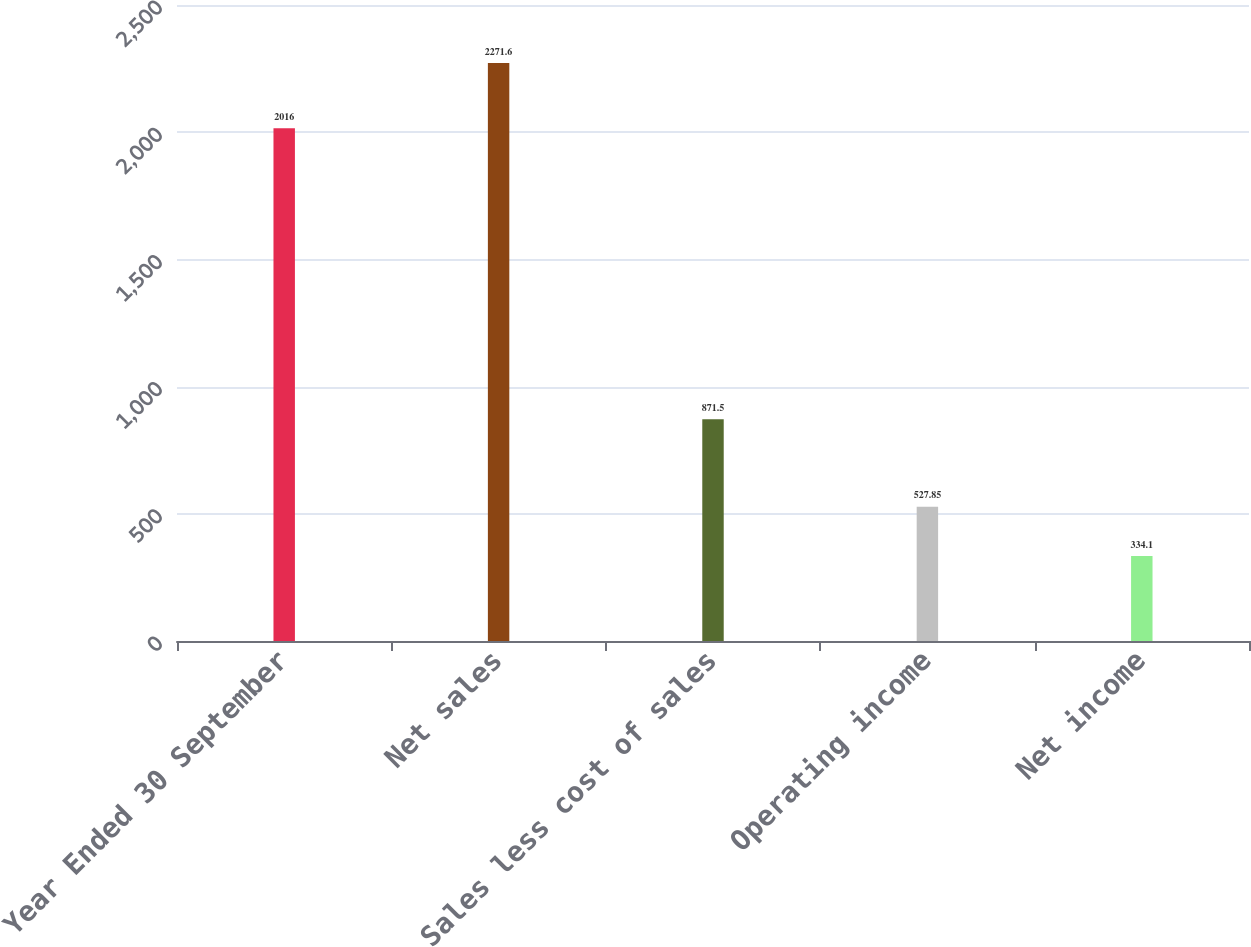Convert chart to OTSL. <chart><loc_0><loc_0><loc_500><loc_500><bar_chart><fcel>Year Ended 30 September<fcel>Net sales<fcel>Sales less cost of sales<fcel>Operating income<fcel>Net income<nl><fcel>2016<fcel>2271.6<fcel>871.5<fcel>527.85<fcel>334.1<nl></chart> 